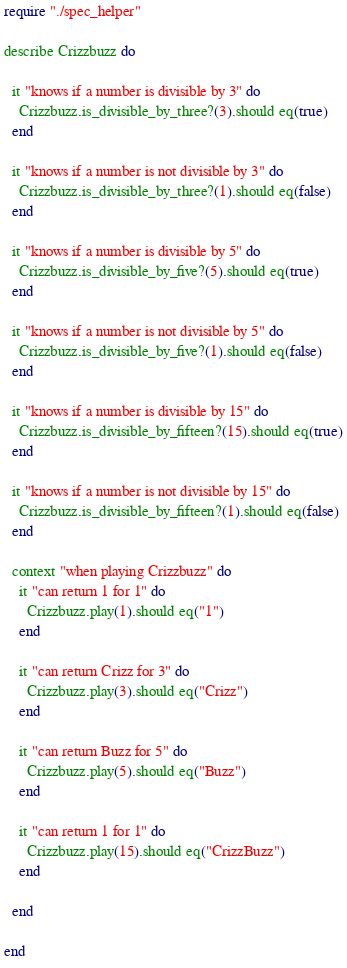<code> <loc_0><loc_0><loc_500><loc_500><_Crystal_>require "./spec_helper"

describe Crizzbuzz do

  it "knows if a number is divisible by 3" do
    Crizzbuzz.is_divisible_by_three?(3).should eq(true)
  end

  it "knows if a number is not divisible by 3" do
    Crizzbuzz.is_divisible_by_three?(1).should eq(false)
  end

  it "knows if a number is divisible by 5" do
    Crizzbuzz.is_divisible_by_five?(5).should eq(true)
  end

  it "knows if a number is not divisible by 5" do
    Crizzbuzz.is_divisible_by_five?(1).should eq(false)
  end

  it "knows if a number is divisible by 15" do
    Crizzbuzz.is_divisible_by_fifteen?(15).should eq(true)
  end

  it "knows if a number is not divisible by 15" do
    Crizzbuzz.is_divisible_by_fifteen?(1).should eq(false)
  end

  context "when playing Crizzbuzz" do
    it "can return 1 for 1" do
      Crizzbuzz.play(1).should eq("1")
    end

    it "can return Crizz for 3" do
      Crizzbuzz.play(3).should eq("Crizz")
    end

    it "can return Buzz for 5" do
      Crizzbuzz.play(5).should eq("Buzz")
    end

    it "can return 1 for 1" do
      Crizzbuzz.play(15).should eq("CrizzBuzz")
    end

  end

end
</code> 